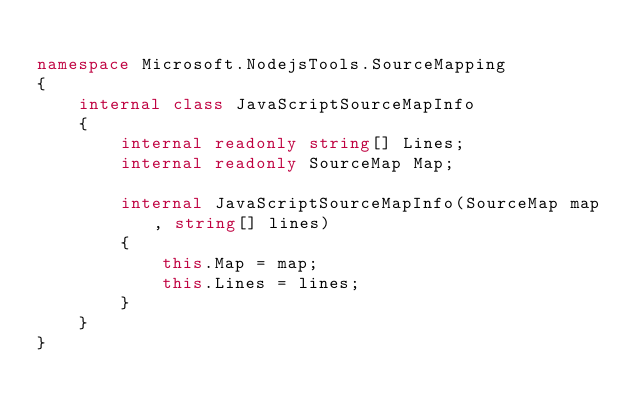<code> <loc_0><loc_0><loc_500><loc_500><_C#_>
namespace Microsoft.NodejsTools.SourceMapping
{
    internal class JavaScriptSourceMapInfo
    {
        internal readonly string[] Lines;
        internal readonly SourceMap Map;

        internal JavaScriptSourceMapInfo(SourceMap map, string[] lines)
        {
            this.Map = map;
            this.Lines = lines;
        }
    }
}
</code> 